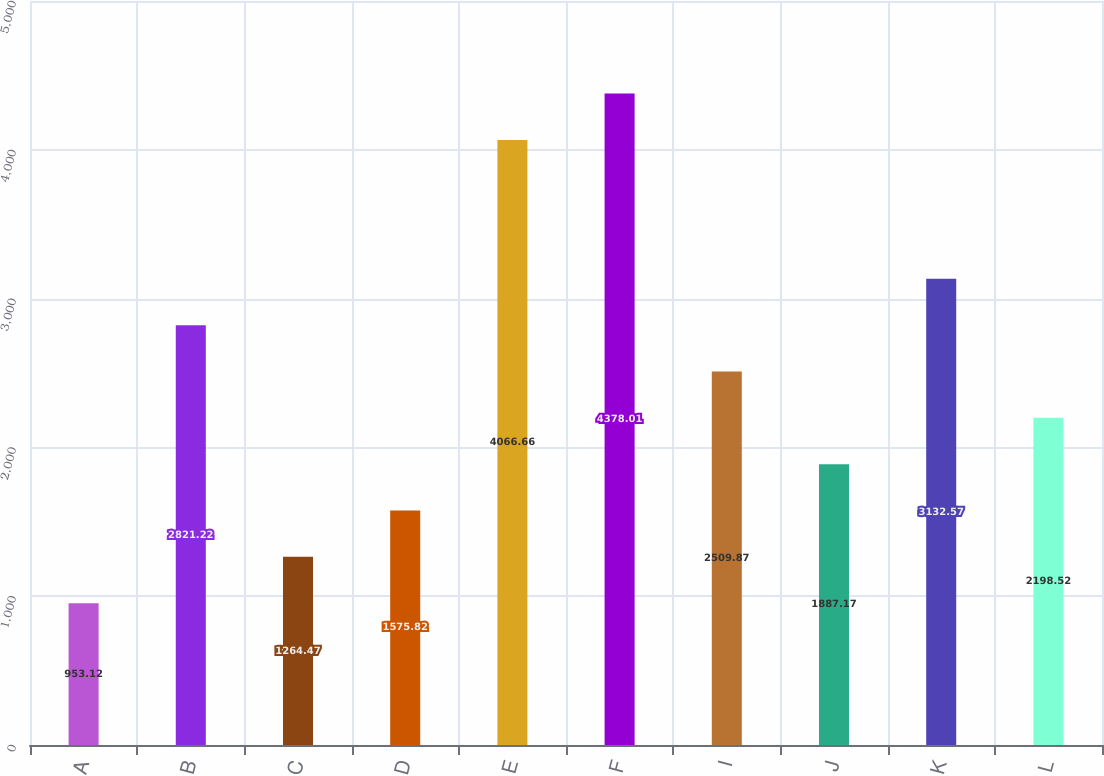<chart> <loc_0><loc_0><loc_500><loc_500><bar_chart><fcel>A<fcel>B<fcel>C<fcel>D<fcel>E<fcel>F<fcel>I<fcel>J<fcel>K<fcel>L<nl><fcel>953.12<fcel>2821.22<fcel>1264.47<fcel>1575.82<fcel>4066.66<fcel>4378.01<fcel>2509.87<fcel>1887.17<fcel>3132.57<fcel>2198.52<nl></chart> 